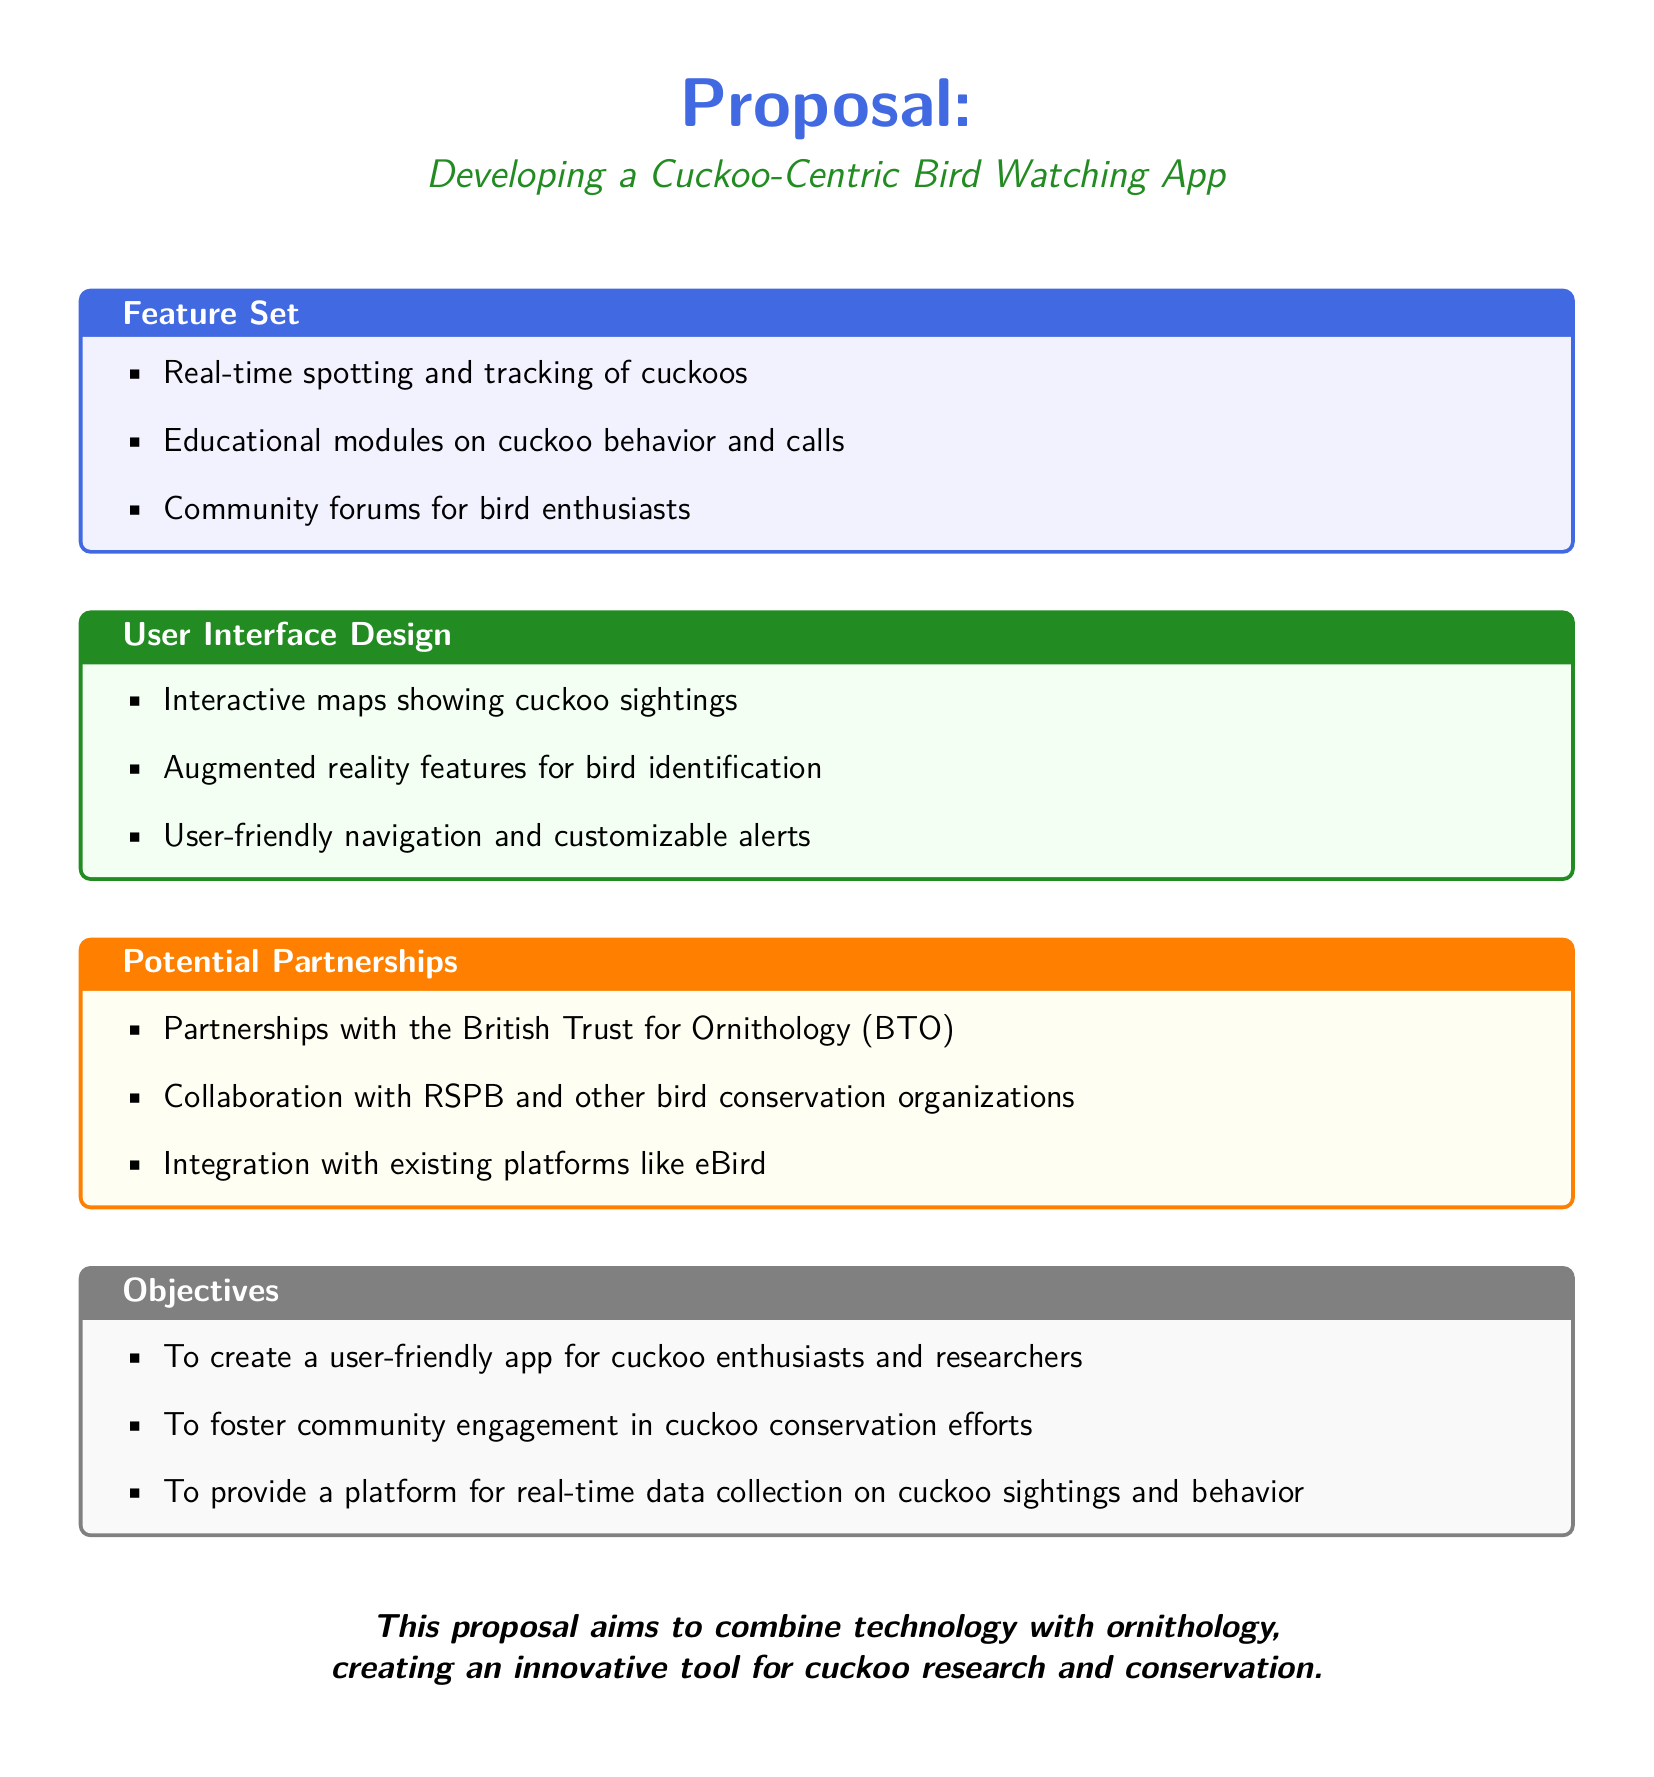What is the title of the proposal? The title of the proposal is presented at the top of the document, emphasizing the focus on a specific app related to cuckoos.
Answer: Developing a Cuckoo-Centric Bird Watching App What are the three main features of the app? The features are listed in a box that specifies what functionalities the app will include.
Answer: Real-time spotting and tracking of cuckoos, Educational modules on cuckoo behavior and calls, Community forums for bird enthusiasts Which organization is mentioned as a potential partnership? The document lists specific organizations that could collaborate on the app initiative, highlighting one of them.
Answer: British Trust for Ornithology (BTO) What is one of the objectives of the app? The objectives are outlined in a section focusing on the goals of creating the app, and one of them is for community purposes.
Answer: To foster community engagement in cuckoo conservation efforts What design feature enhances bird identification? The document details several design elements, one of which uses technology to assist users in identifying birds.
Answer: Augmented reality features for bird identification How many objectives are listed in the proposal? The objectives are clearly enumerated in a section, indicating how many specific goals the proposal has outlined.
Answer: Three 